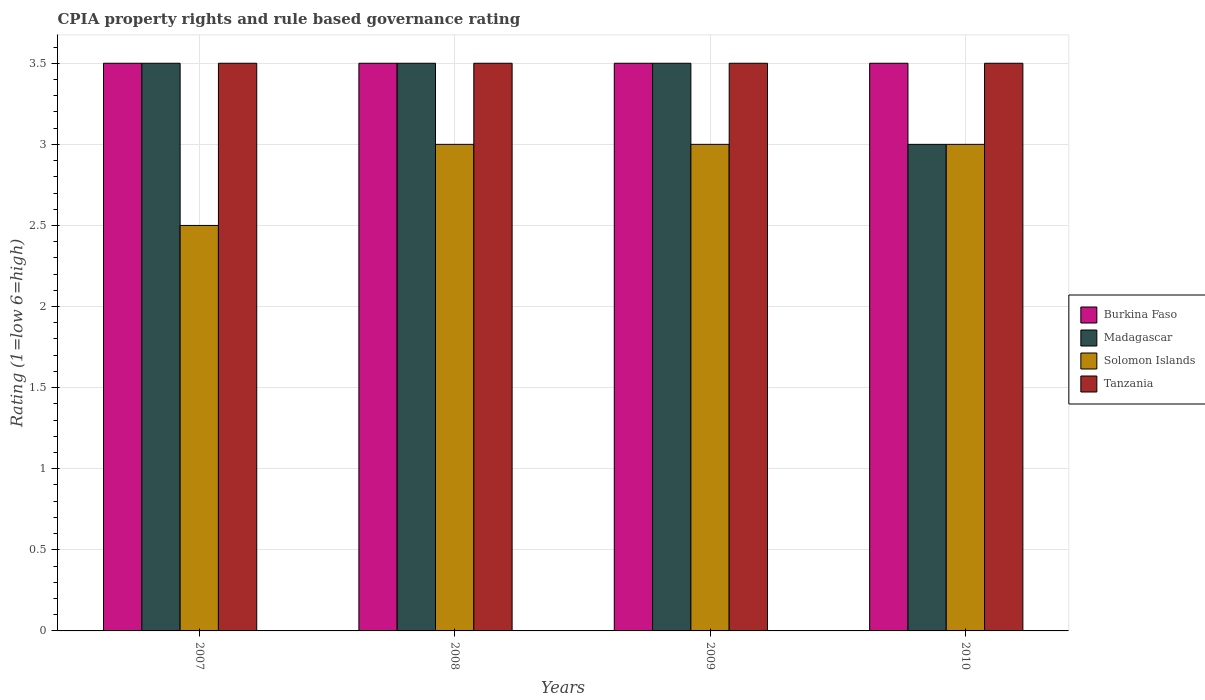Are the number of bars per tick equal to the number of legend labels?
Give a very brief answer. Yes. Are the number of bars on each tick of the X-axis equal?
Your answer should be very brief. Yes. How many bars are there on the 3rd tick from the left?
Your answer should be compact. 4. How many bars are there on the 2nd tick from the right?
Your answer should be very brief. 4. In how many cases, is the number of bars for a given year not equal to the number of legend labels?
Your answer should be very brief. 0. What is the CPIA rating in Madagascar in 2007?
Provide a succinct answer. 3.5. Across all years, what is the maximum CPIA rating in Solomon Islands?
Your answer should be very brief. 3. Across all years, what is the minimum CPIA rating in Solomon Islands?
Offer a terse response. 2.5. In which year was the CPIA rating in Burkina Faso maximum?
Ensure brevity in your answer.  2007. In which year was the CPIA rating in Burkina Faso minimum?
Your answer should be compact. 2007. What is the total CPIA rating in Tanzania in the graph?
Ensure brevity in your answer.  14. What is the average CPIA rating in Solomon Islands per year?
Keep it short and to the point. 2.88. Is the CPIA rating in Tanzania in 2009 less than that in 2010?
Make the answer very short. No. Is the difference between the CPIA rating in Solomon Islands in 2007 and 2010 greater than the difference between the CPIA rating in Tanzania in 2007 and 2010?
Your answer should be compact. No. What is the difference between the highest and the lowest CPIA rating in Solomon Islands?
Keep it short and to the point. 0.5. Is the sum of the CPIA rating in Burkina Faso in 2008 and 2009 greater than the maximum CPIA rating in Tanzania across all years?
Your answer should be compact. Yes. Is it the case that in every year, the sum of the CPIA rating in Burkina Faso and CPIA rating in Madagascar is greater than the sum of CPIA rating in Tanzania and CPIA rating in Solomon Islands?
Provide a succinct answer. No. What does the 3rd bar from the left in 2008 represents?
Ensure brevity in your answer.  Solomon Islands. What does the 3rd bar from the right in 2007 represents?
Your response must be concise. Madagascar. Are all the bars in the graph horizontal?
Offer a terse response. No. What is the difference between two consecutive major ticks on the Y-axis?
Provide a short and direct response. 0.5. Are the values on the major ticks of Y-axis written in scientific E-notation?
Your answer should be compact. No. Does the graph contain any zero values?
Give a very brief answer. No. Does the graph contain grids?
Provide a short and direct response. Yes. How many legend labels are there?
Your response must be concise. 4. How are the legend labels stacked?
Your answer should be compact. Vertical. What is the title of the graph?
Your answer should be compact. CPIA property rights and rule based governance rating. Does "Solomon Islands" appear as one of the legend labels in the graph?
Give a very brief answer. Yes. What is the label or title of the X-axis?
Your response must be concise. Years. What is the label or title of the Y-axis?
Provide a succinct answer. Rating (1=low 6=high). What is the Rating (1=low 6=high) in Madagascar in 2007?
Your response must be concise. 3.5. What is the Rating (1=low 6=high) in Solomon Islands in 2007?
Keep it short and to the point. 2.5. What is the Rating (1=low 6=high) of Tanzania in 2007?
Keep it short and to the point. 3.5. What is the Rating (1=low 6=high) of Burkina Faso in 2008?
Provide a short and direct response. 3.5. What is the Rating (1=low 6=high) in Madagascar in 2008?
Provide a succinct answer. 3.5. What is the Rating (1=low 6=high) of Solomon Islands in 2008?
Make the answer very short. 3. What is the Rating (1=low 6=high) of Madagascar in 2009?
Keep it short and to the point. 3.5. What is the Rating (1=low 6=high) of Solomon Islands in 2009?
Your answer should be compact. 3. What is the Rating (1=low 6=high) in Tanzania in 2009?
Ensure brevity in your answer.  3.5. What is the Rating (1=low 6=high) in Burkina Faso in 2010?
Provide a succinct answer. 3.5. What is the Rating (1=low 6=high) in Madagascar in 2010?
Your response must be concise. 3. What is the Rating (1=low 6=high) in Solomon Islands in 2010?
Give a very brief answer. 3. What is the Rating (1=low 6=high) in Tanzania in 2010?
Provide a short and direct response. 3.5. Across all years, what is the maximum Rating (1=low 6=high) of Burkina Faso?
Ensure brevity in your answer.  3.5. Across all years, what is the maximum Rating (1=low 6=high) in Madagascar?
Provide a short and direct response. 3.5. Across all years, what is the minimum Rating (1=low 6=high) of Burkina Faso?
Provide a short and direct response. 3.5. Across all years, what is the minimum Rating (1=low 6=high) of Solomon Islands?
Give a very brief answer. 2.5. What is the total Rating (1=low 6=high) in Solomon Islands in the graph?
Give a very brief answer. 11.5. What is the total Rating (1=low 6=high) in Tanzania in the graph?
Keep it short and to the point. 14. What is the difference between the Rating (1=low 6=high) in Burkina Faso in 2007 and that in 2008?
Provide a short and direct response. 0. What is the difference between the Rating (1=low 6=high) of Madagascar in 2007 and that in 2008?
Ensure brevity in your answer.  0. What is the difference between the Rating (1=low 6=high) in Solomon Islands in 2007 and that in 2008?
Provide a succinct answer. -0.5. What is the difference between the Rating (1=low 6=high) of Burkina Faso in 2007 and that in 2009?
Give a very brief answer. 0. What is the difference between the Rating (1=low 6=high) in Solomon Islands in 2007 and that in 2009?
Give a very brief answer. -0.5. What is the difference between the Rating (1=low 6=high) in Madagascar in 2007 and that in 2010?
Provide a succinct answer. 0.5. What is the difference between the Rating (1=low 6=high) of Madagascar in 2008 and that in 2009?
Ensure brevity in your answer.  0. What is the difference between the Rating (1=low 6=high) in Solomon Islands in 2008 and that in 2009?
Ensure brevity in your answer.  0. What is the difference between the Rating (1=low 6=high) in Tanzania in 2008 and that in 2009?
Provide a succinct answer. 0. What is the difference between the Rating (1=low 6=high) of Madagascar in 2008 and that in 2010?
Offer a very short reply. 0.5. What is the difference between the Rating (1=low 6=high) of Burkina Faso in 2009 and that in 2010?
Provide a succinct answer. 0. What is the difference between the Rating (1=low 6=high) of Madagascar in 2009 and that in 2010?
Your response must be concise. 0.5. What is the difference between the Rating (1=low 6=high) in Solomon Islands in 2009 and that in 2010?
Provide a succinct answer. 0. What is the difference between the Rating (1=low 6=high) in Tanzania in 2009 and that in 2010?
Offer a terse response. 0. What is the difference between the Rating (1=low 6=high) of Burkina Faso in 2007 and the Rating (1=low 6=high) of Madagascar in 2008?
Offer a terse response. 0. What is the difference between the Rating (1=low 6=high) in Madagascar in 2007 and the Rating (1=low 6=high) in Solomon Islands in 2008?
Offer a terse response. 0.5. What is the difference between the Rating (1=low 6=high) in Solomon Islands in 2007 and the Rating (1=low 6=high) in Tanzania in 2008?
Provide a succinct answer. -1. What is the difference between the Rating (1=low 6=high) in Burkina Faso in 2007 and the Rating (1=low 6=high) in Madagascar in 2009?
Your answer should be compact. 0. What is the difference between the Rating (1=low 6=high) in Burkina Faso in 2007 and the Rating (1=low 6=high) in Solomon Islands in 2009?
Provide a succinct answer. 0.5. What is the difference between the Rating (1=low 6=high) of Burkina Faso in 2007 and the Rating (1=low 6=high) of Tanzania in 2009?
Your answer should be compact. 0. What is the difference between the Rating (1=low 6=high) of Solomon Islands in 2007 and the Rating (1=low 6=high) of Tanzania in 2009?
Offer a very short reply. -1. What is the difference between the Rating (1=low 6=high) in Burkina Faso in 2007 and the Rating (1=low 6=high) in Solomon Islands in 2010?
Ensure brevity in your answer.  0.5. What is the difference between the Rating (1=low 6=high) in Madagascar in 2007 and the Rating (1=low 6=high) in Solomon Islands in 2010?
Provide a succinct answer. 0.5. What is the difference between the Rating (1=low 6=high) of Burkina Faso in 2008 and the Rating (1=low 6=high) of Solomon Islands in 2009?
Provide a short and direct response. 0.5. What is the difference between the Rating (1=low 6=high) in Madagascar in 2008 and the Rating (1=low 6=high) in Tanzania in 2009?
Offer a very short reply. 0. What is the difference between the Rating (1=low 6=high) of Burkina Faso in 2008 and the Rating (1=low 6=high) of Madagascar in 2010?
Ensure brevity in your answer.  0.5. What is the difference between the Rating (1=low 6=high) in Burkina Faso in 2008 and the Rating (1=low 6=high) in Solomon Islands in 2010?
Offer a terse response. 0.5. What is the difference between the Rating (1=low 6=high) of Burkina Faso in 2008 and the Rating (1=low 6=high) of Tanzania in 2010?
Offer a terse response. 0. What is the difference between the Rating (1=low 6=high) of Madagascar in 2008 and the Rating (1=low 6=high) of Solomon Islands in 2010?
Provide a short and direct response. 0.5. What is the difference between the Rating (1=low 6=high) of Madagascar in 2009 and the Rating (1=low 6=high) of Solomon Islands in 2010?
Your response must be concise. 0.5. What is the difference between the Rating (1=low 6=high) of Madagascar in 2009 and the Rating (1=low 6=high) of Tanzania in 2010?
Your response must be concise. 0. What is the difference between the Rating (1=low 6=high) in Solomon Islands in 2009 and the Rating (1=low 6=high) in Tanzania in 2010?
Give a very brief answer. -0.5. What is the average Rating (1=low 6=high) of Burkina Faso per year?
Offer a very short reply. 3.5. What is the average Rating (1=low 6=high) of Madagascar per year?
Ensure brevity in your answer.  3.38. What is the average Rating (1=low 6=high) in Solomon Islands per year?
Give a very brief answer. 2.88. In the year 2007, what is the difference between the Rating (1=low 6=high) in Burkina Faso and Rating (1=low 6=high) in Madagascar?
Keep it short and to the point. 0. In the year 2007, what is the difference between the Rating (1=low 6=high) of Burkina Faso and Rating (1=low 6=high) of Solomon Islands?
Provide a succinct answer. 1. In the year 2007, what is the difference between the Rating (1=low 6=high) in Burkina Faso and Rating (1=low 6=high) in Tanzania?
Keep it short and to the point. 0. In the year 2007, what is the difference between the Rating (1=low 6=high) of Madagascar and Rating (1=low 6=high) of Tanzania?
Your answer should be compact. 0. In the year 2007, what is the difference between the Rating (1=low 6=high) in Solomon Islands and Rating (1=low 6=high) in Tanzania?
Offer a very short reply. -1. In the year 2008, what is the difference between the Rating (1=low 6=high) of Burkina Faso and Rating (1=low 6=high) of Madagascar?
Provide a succinct answer. 0. In the year 2008, what is the difference between the Rating (1=low 6=high) in Burkina Faso and Rating (1=low 6=high) in Solomon Islands?
Provide a short and direct response. 0.5. In the year 2008, what is the difference between the Rating (1=low 6=high) in Madagascar and Rating (1=low 6=high) in Solomon Islands?
Give a very brief answer. 0.5. In the year 2008, what is the difference between the Rating (1=low 6=high) in Solomon Islands and Rating (1=low 6=high) in Tanzania?
Provide a succinct answer. -0.5. In the year 2009, what is the difference between the Rating (1=low 6=high) in Madagascar and Rating (1=low 6=high) in Solomon Islands?
Give a very brief answer. 0.5. In the year 2009, what is the difference between the Rating (1=low 6=high) of Madagascar and Rating (1=low 6=high) of Tanzania?
Your answer should be compact. 0. In the year 2009, what is the difference between the Rating (1=low 6=high) of Solomon Islands and Rating (1=low 6=high) of Tanzania?
Give a very brief answer. -0.5. In the year 2010, what is the difference between the Rating (1=low 6=high) in Burkina Faso and Rating (1=low 6=high) in Madagascar?
Your response must be concise. 0.5. In the year 2010, what is the difference between the Rating (1=low 6=high) of Burkina Faso and Rating (1=low 6=high) of Solomon Islands?
Give a very brief answer. 0.5. In the year 2010, what is the difference between the Rating (1=low 6=high) in Madagascar and Rating (1=low 6=high) in Tanzania?
Give a very brief answer. -0.5. In the year 2010, what is the difference between the Rating (1=low 6=high) in Solomon Islands and Rating (1=low 6=high) in Tanzania?
Make the answer very short. -0.5. What is the ratio of the Rating (1=low 6=high) of Burkina Faso in 2007 to that in 2008?
Offer a terse response. 1. What is the ratio of the Rating (1=low 6=high) of Madagascar in 2007 to that in 2008?
Offer a very short reply. 1. What is the ratio of the Rating (1=low 6=high) in Burkina Faso in 2007 to that in 2009?
Provide a succinct answer. 1. What is the ratio of the Rating (1=low 6=high) in Madagascar in 2007 to that in 2009?
Give a very brief answer. 1. What is the ratio of the Rating (1=low 6=high) in Solomon Islands in 2007 to that in 2009?
Provide a succinct answer. 0.83. What is the ratio of the Rating (1=low 6=high) in Tanzania in 2007 to that in 2009?
Your answer should be very brief. 1. What is the ratio of the Rating (1=low 6=high) of Madagascar in 2007 to that in 2010?
Give a very brief answer. 1.17. What is the ratio of the Rating (1=low 6=high) in Solomon Islands in 2007 to that in 2010?
Provide a short and direct response. 0.83. What is the ratio of the Rating (1=low 6=high) of Tanzania in 2007 to that in 2010?
Offer a terse response. 1. What is the ratio of the Rating (1=low 6=high) of Madagascar in 2008 to that in 2009?
Offer a terse response. 1. What is the ratio of the Rating (1=low 6=high) in Solomon Islands in 2008 to that in 2009?
Provide a short and direct response. 1. What is the ratio of the Rating (1=low 6=high) of Tanzania in 2008 to that in 2009?
Your answer should be very brief. 1. What is the ratio of the Rating (1=low 6=high) of Burkina Faso in 2008 to that in 2010?
Your response must be concise. 1. What is the ratio of the Rating (1=low 6=high) of Solomon Islands in 2008 to that in 2010?
Your answer should be very brief. 1. What is the ratio of the Rating (1=low 6=high) in Burkina Faso in 2009 to that in 2010?
Make the answer very short. 1. What is the ratio of the Rating (1=low 6=high) in Madagascar in 2009 to that in 2010?
Offer a very short reply. 1.17. What is the difference between the highest and the second highest Rating (1=low 6=high) of Solomon Islands?
Your response must be concise. 0. What is the difference between the highest and the second highest Rating (1=low 6=high) of Tanzania?
Make the answer very short. 0. What is the difference between the highest and the lowest Rating (1=low 6=high) of Burkina Faso?
Your answer should be compact. 0. 